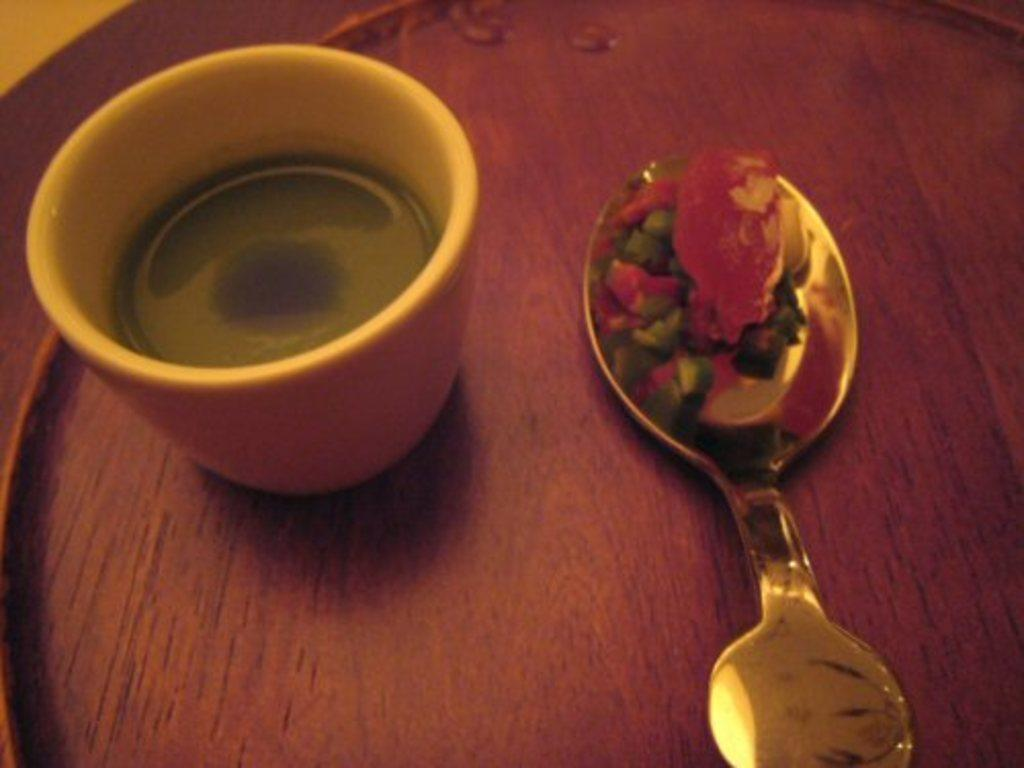What is present on the wooden surface in the image? There is a cup and a spoon on the wooden surface in the image. What type of surface is the cup and spoon placed on? The wooden surface suggests a table or countertop. Can you describe the utensil in the image? There is a spoon in the image. What type of town is depicted in the image? There is no town present in the image; it only features a cup, spoon, and wooden surface. What kind of lumber is used to make the wooden surface in the image? The type of lumber used to make the wooden surface is not mentioned in the image or the provided facts. 